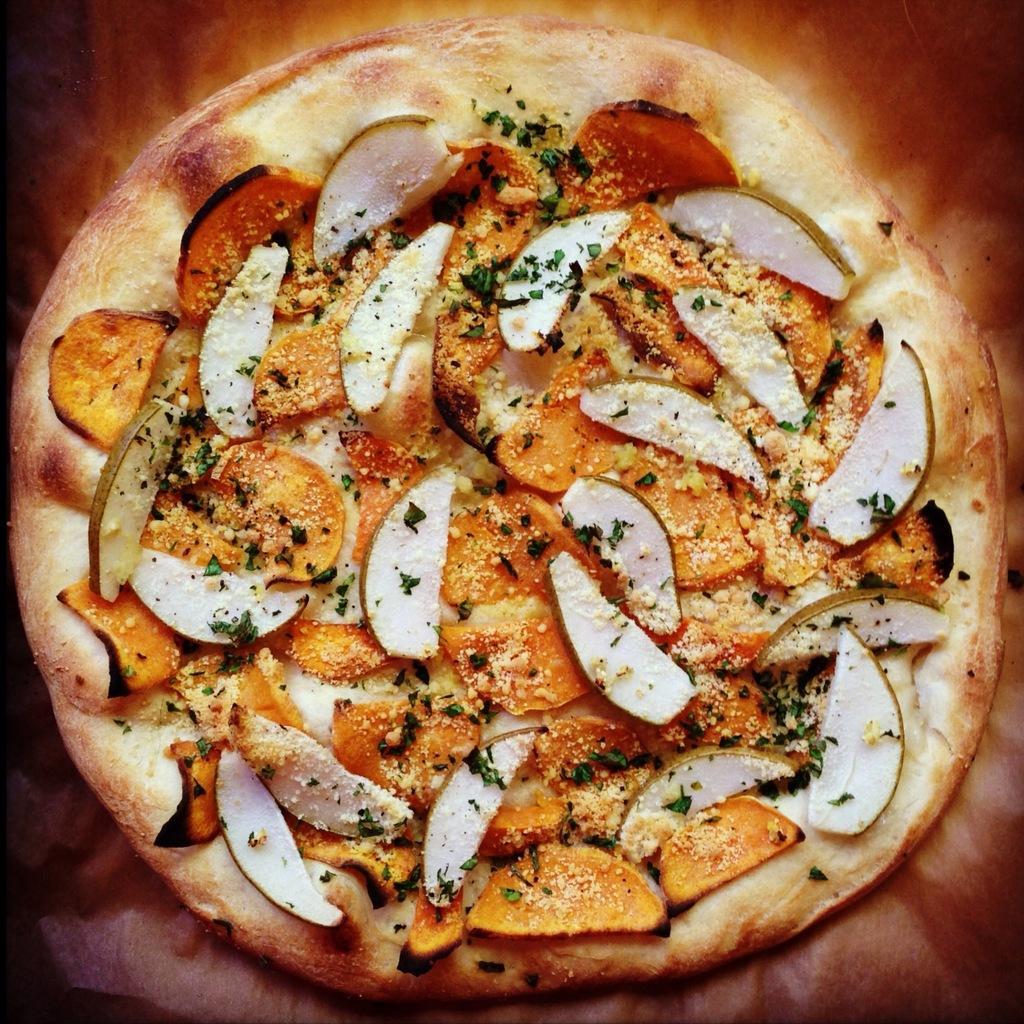Describe this image in one or two sentences. In this image we can see a food item, on that there are some vegetable slices, and the background is blurred. 